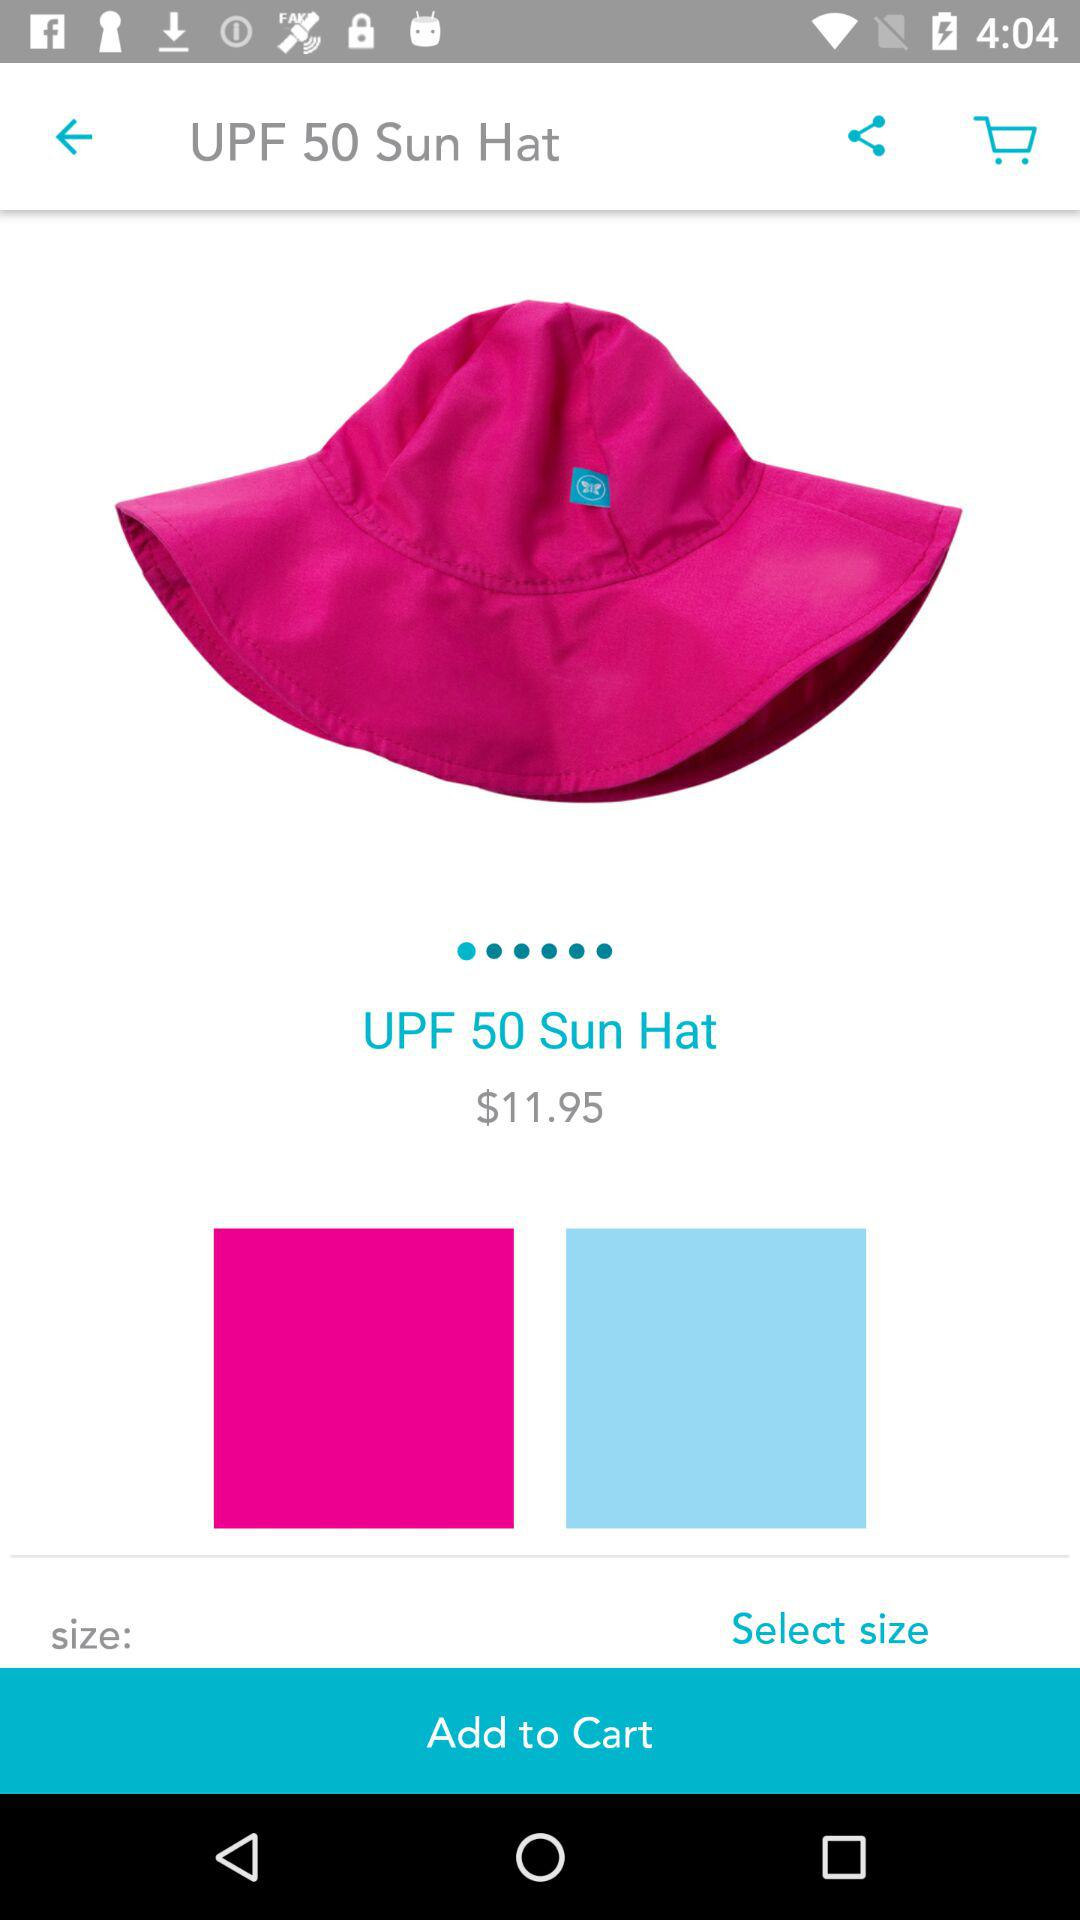What is the price of "UPF 50 Sun Hat"? The price is $11.95. 